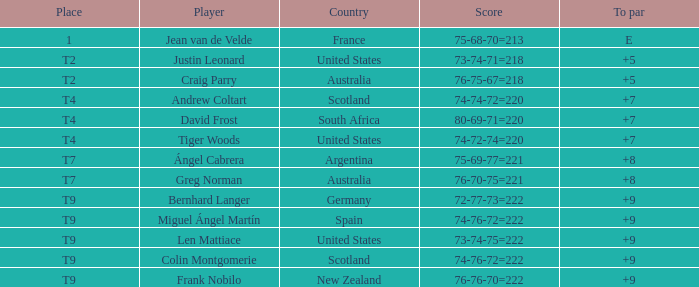Which u.s. player is currently situated at t2? Justin Leonard. 